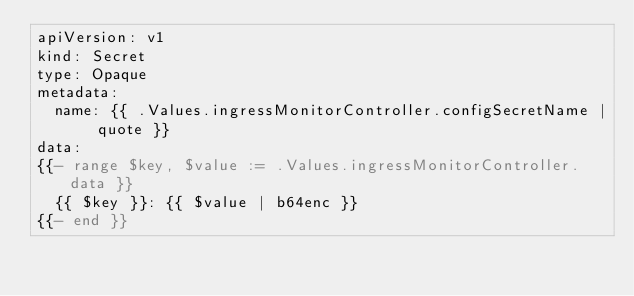Convert code to text. <code><loc_0><loc_0><loc_500><loc_500><_YAML_>apiVersion: v1
kind: Secret
type: Opaque
metadata:
  name: {{ .Values.ingressMonitorController.configSecretName | quote }}
data:
{{- range $key, $value := .Values.ingressMonitorController.data }}
  {{ $key }}: {{ $value | b64enc }}
{{- end }}
</code> 